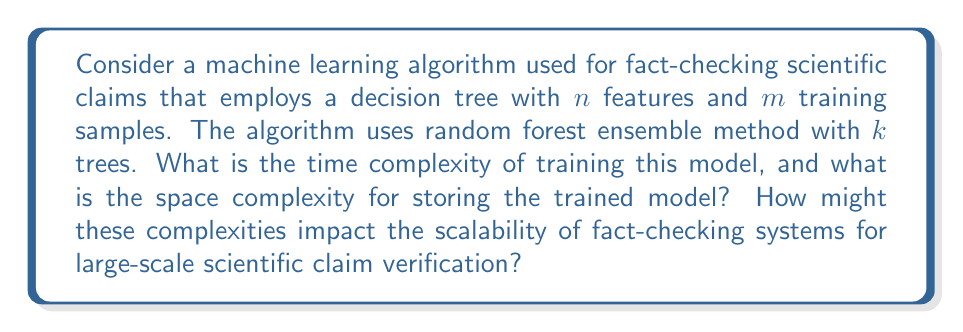Teach me how to tackle this problem. To analyze the time and space complexity of this machine learning algorithm, we need to consider both the training phase and the storage requirements of the trained model.

1. Time Complexity:
   The time complexity of training a single decision tree is generally $O(n \cdot m \log m)$, where:
   - $n$ is the number of features
   - $m$ is the number of training samples

   This is because at each node, we need to sort the samples for each feature to find the best split, which takes $O(m \log m)$ time, and we do this for $n$ features.

   For a random forest with $k$ trees, we repeat this process $k$ times. However, each tree is typically trained on a bootstrap sample of the original dataset, which has the same size as the original dataset but is sampled with replacement.

   Therefore, the total time complexity for training the random forest is:

   $$O(k \cdot n \cdot m \log m)$$

2. Space Complexity:
   For storing the trained model, we need to consider the space required for each tree in the random forest.

   The space complexity of a single decision tree is $O(p)$, where $p$ is the number of nodes in the tree. In the worst case, where the tree is completely imbalanced, $p$ could be equal to $m$. However, in practice, it's usually much less.

   For a random forest with $k$ trees, the space complexity becomes:

   $$O(k \cdot p)$$

   Where $p$ is the average number of nodes across all trees.

Impact on scalability:
1. Time scalability: The logarithmic factor in the time complexity ($\log m$) means that the training time grows slower than linearly with the number of samples. However, it still increases with both the number of features and the number of trees. For large-scale fact-checking systems dealing with vast amounts of scientific claims, this could lead to long training times.

2. Space scalability: The space complexity is linear in the number of trees ($k$) and the average tree size ($p$). This could become a bottleneck for very large models, especially when dealing with a wide variety of scientific domains that might require a large number of features and trees to achieve high accuracy.

3. Trade-offs: There's a trade-off between model complexity (which affects accuracy) and computational resources. More complex models (higher $k$ and $n$) may provide better accuracy but at the cost of increased time and space requirements.

4. Parallelization: One advantage of random forests is that the training of individual trees can be parallelized, which can help mitigate the time complexity issues on multi-core systems or distributed computing environments.

5. Incremental learning: For continually updated fact-checking systems, techniques for incremental learning or model updating could be crucial to avoid retraining the entire model from scratch as new scientific claims emerge.
Answer: Time complexity: $O(k \cdot n \cdot m \log m)$
Space complexity: $O(k \cdot p)$
Where $k$ is the number of trees, $n$ is the number of features, $m$ is the number of training samples, and $p$ is the average number of nodes per tree. 